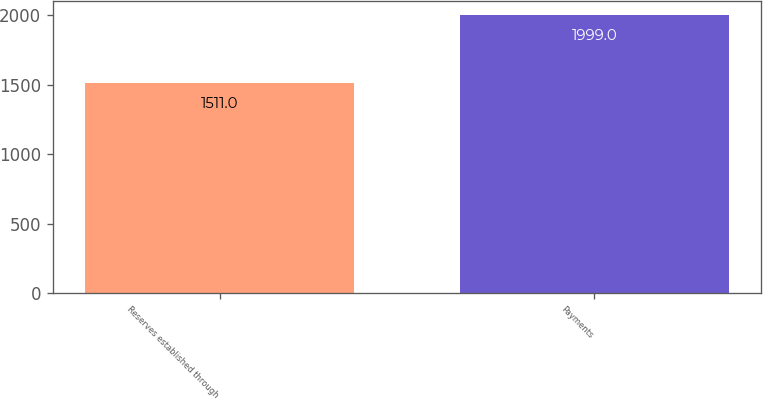Convert chart. <chart><loc_0><loc_0><loc_500><loc_500><bar_chart><fcel>Reserves established through<fcel>Payments<nl><fcel>1511<fcel>1999<nl></chart> 